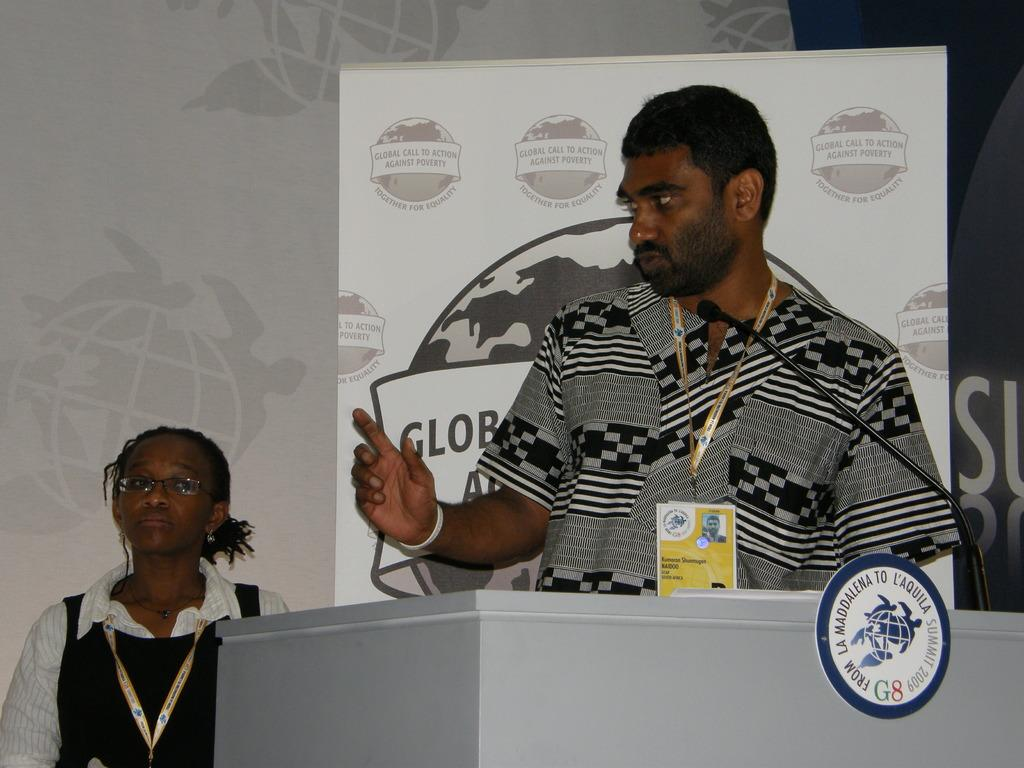How many people are present in the image? There is a woman and a man present in the image. What are the woman and man wearing in the image? The woman and man are wearing ID cards in the image. What can be seen behind the woman and man? There is a podium, a board, a mic, and banners visible in the image. What year is depicted on the banners in the image? There is no year mentioned on the banners in the image. Can you tell me how the woman and man are preparing for their voyage in the image? There is no indication of a voyage in the image; it appears to be a presentation or event setting. 